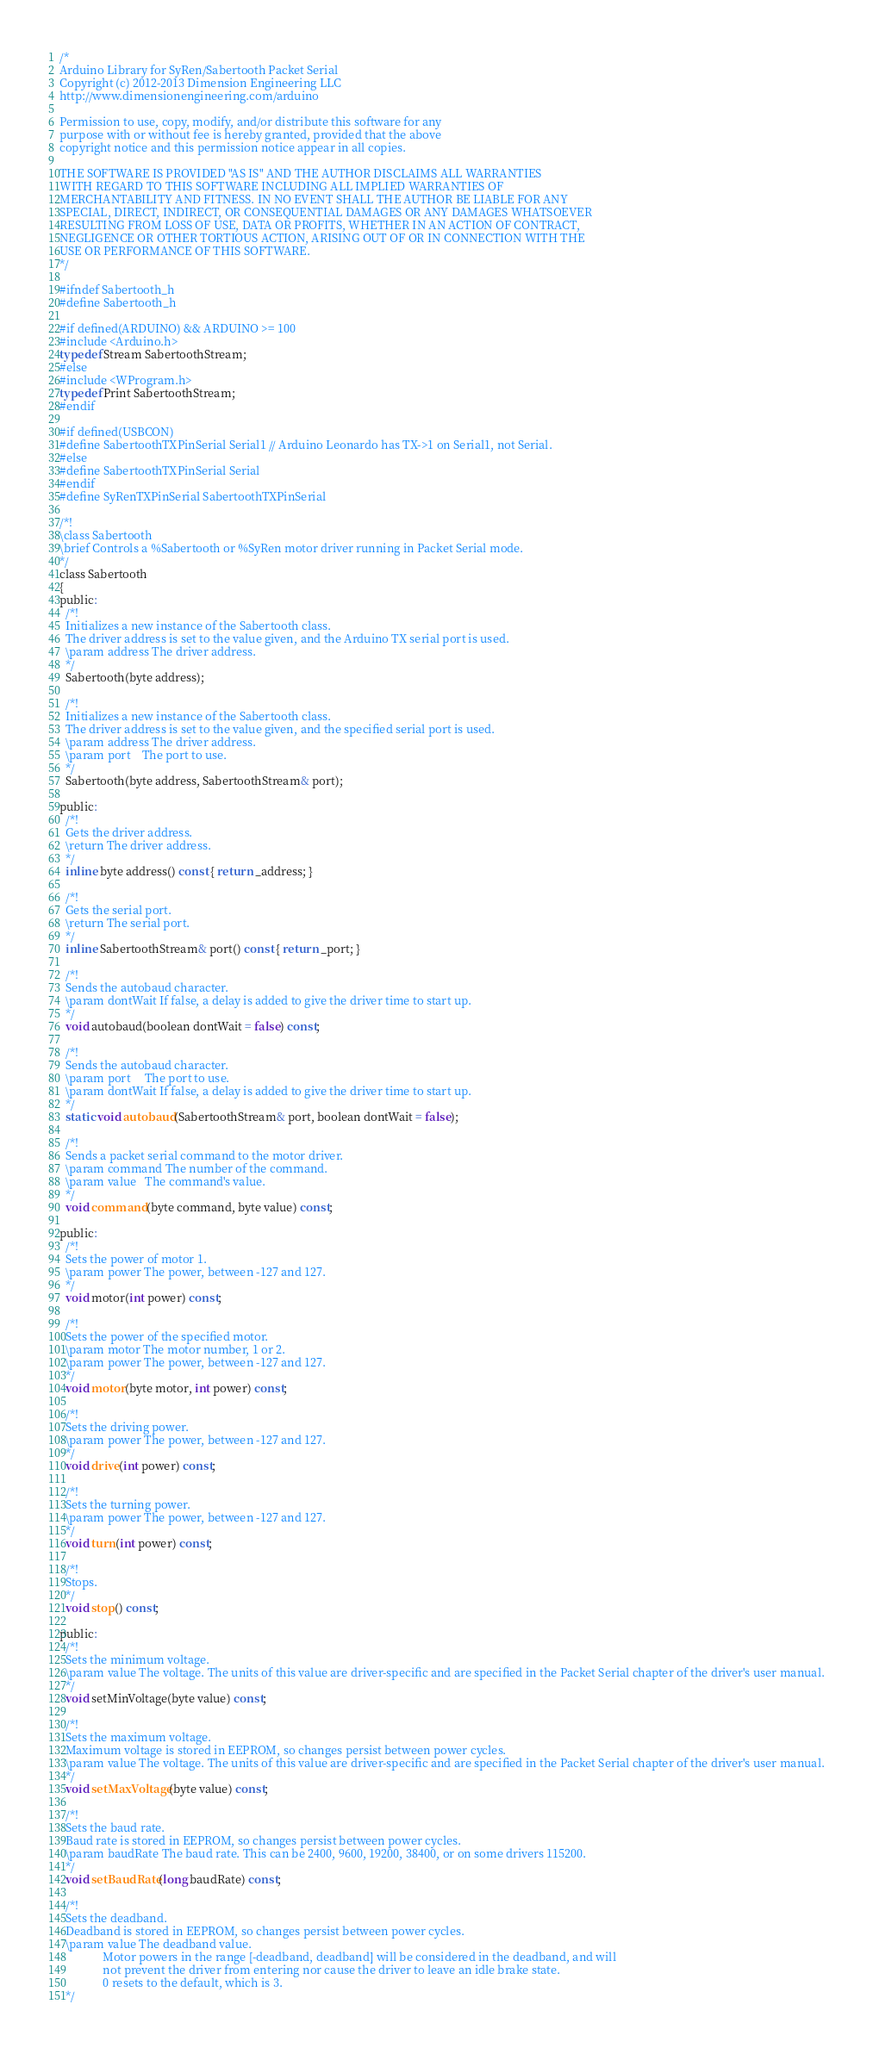Convert code to text. <code><loc_0><loc_0><loc_500><loc_500><_C_>/*
Arduino Library for SyRen/Sabertooth Packet Serial
Copyright (c) 2012-2013 Dimension Engineering LLC
http://www.dimensionengineering.com/arduino

Permission to use, copy, modify, and/or distribute this software for any
purpose with or without fee is hereby granted, provided that the above
copyright notice and this permission notice appear in all copies.

THE SOFTWARE IS PROVIDED "AS IS" AND THE AUTHOR DISCLAIMS ALL WARRANTIES
WITH REGARD TO THIS SOFTWARE INCLUDING ALL IMPLIED WARRANTIES OF
MERCHANTABILITY AND FITNESS. IN NO EVENT SHALL THE AUTHOR BE LIABLE FOR ANY
SPECIAL, DIRECT, INDIRECT, OR CONSEQUENTIAL DAMAGES OR ANY DAMAGES WHATSOEVER
RESULTING FROM LOSS OF USE, DATA OR PROFITS, WHETHER IN AN ACTION OF CONTRACT,
NEGLIGENCE OR OTHER TORTIOUS ACTION, ARISING OUT OF OR IN CONNECTION WITH THE
USE OR PERFORMANCE OF THIS SOFTWARE.
*/

#ifndef Sabertooth_h
#define Sabertooth_h   

#if defined(ARDUINO) && ARDUINO >= 100
#include <Arduino.h>
typedef Stream SabertoothStream;
#else
#include <WProgram.h>
typedef Print SabertoothStream;
#endif

#if defined(USBCON)
#define SabertoothTXPinSerial Serial1 // Arduino Leonardo has TX->1 on Serial1, not Serial.
#else
#define SabertoothTXPinSerial Serial
#endif
#define SyRenTXPinSerial SabertoothTXPinSerial

/*!
\class Sabertooth
\brief Controls a %Sabertooth or %SyRen motor driver running in Packet Serial mode.
*/
class Sabertooth
{
public:
  /*!
  Initializes a new instance of the Sabertooth class.
  The driver address is set to the value given, and the Arduino TX serial port is used.
  \param address The driver address.
  */
  Sabertooth(byte address);
  
  /*!
  Initializes a new instance of the Sabertooth class.
  The driver address is set to the value given, and the specified serial port is used.
  \param address The driver address.
  \param port    The port to use.
  */
  Sabertooth(byte address, SabertoothStream& port);

public:
  /*!
  Gets the driver address.
  \return The driver address.
  */
  inline byte address() const { return _address; }
  
  /*!
  Gets the serial port.
  \return The serial port.
  */
  inline SabertoothStream& port() const { return _port; }

  /*!
  Sends the autobaud character.
  \param dontWait If false, a delay is added to give the driver time to start up.
  */
  void autobaud(boolean dontWait = false) const;
  
  /*!
  Sends the autobaud character.
  \param port     The port to use.
  \param dontWait If false, a delay is added to give the driver time to start up.
  */
  static void autobaud(SabertoothStream& port, boolean dontWait = false);
  
  /*!
  Sends a packet serial command to the motor driver.
  \param command The number of the command.
  \param value   The command's value.
  */
  void command(byte command, byte value) const;
  
public:
  /*!
  Sets the power of motor 1.
  \param power The power, between -127 and 127.
  */
  void motor(int power) const;
  
  /*!
  Sets the power of the specified motor.
  \param motor The motor number, 1 or 2.
  \param power The power, between -127 and 127.
  */
  void motor(byte motor, int power) const;
  
  /*!
  Sets the driving power.
  \param power The power, between -127 and 127.
  */
  void drive(int power) const;
  
  /*!
  Sets the turning power.
  \param power The power, between -127 and 127.
  */
  void turn(int power) const;
  
  /*!
  Stops.
  */
  void stop() const;
  
public:
  /*!
  Sets the minimum voltage.
  \param value The voltage. The units of this value are driver-specific and are specified in the Packet Serial chapter of the driver's user manual.
  */
  void setMinVoltage(byte value) const;
  
  /*!
  Sets the maximum voltage.
  Maximum voltage is stored in EEPROM, so changes persist between power cycles.
  \param value The voltage. The units of this value are driver-specific and are specified in the Packet Serial chapter of the driver's user manual.
  */
  void setMaxVoltage(byte value) const;
  
  /*!
  Sets the baud rate.
  Baud rate is stored in EEPROM, so changes persist between power cycles.
  \param baudRate The baud rate. This can be 2400, 9600, 19200, 38400, or on some drivers 115200.
  */
  void setBaudRate(long baudRate) const;
  
  /*!
  Sets the deadband.
  Deadband is stored in EEPROM, so changes persist between power cycles.
  \param value The deadband value.
               Motor powers in the range [-deadband, deadband] will be considered in the deadband, and will
               not prevent the driver from entering nor cause the driver to leave an idle brake state.
               0 resets to the default, which is 3.
  */</code> 